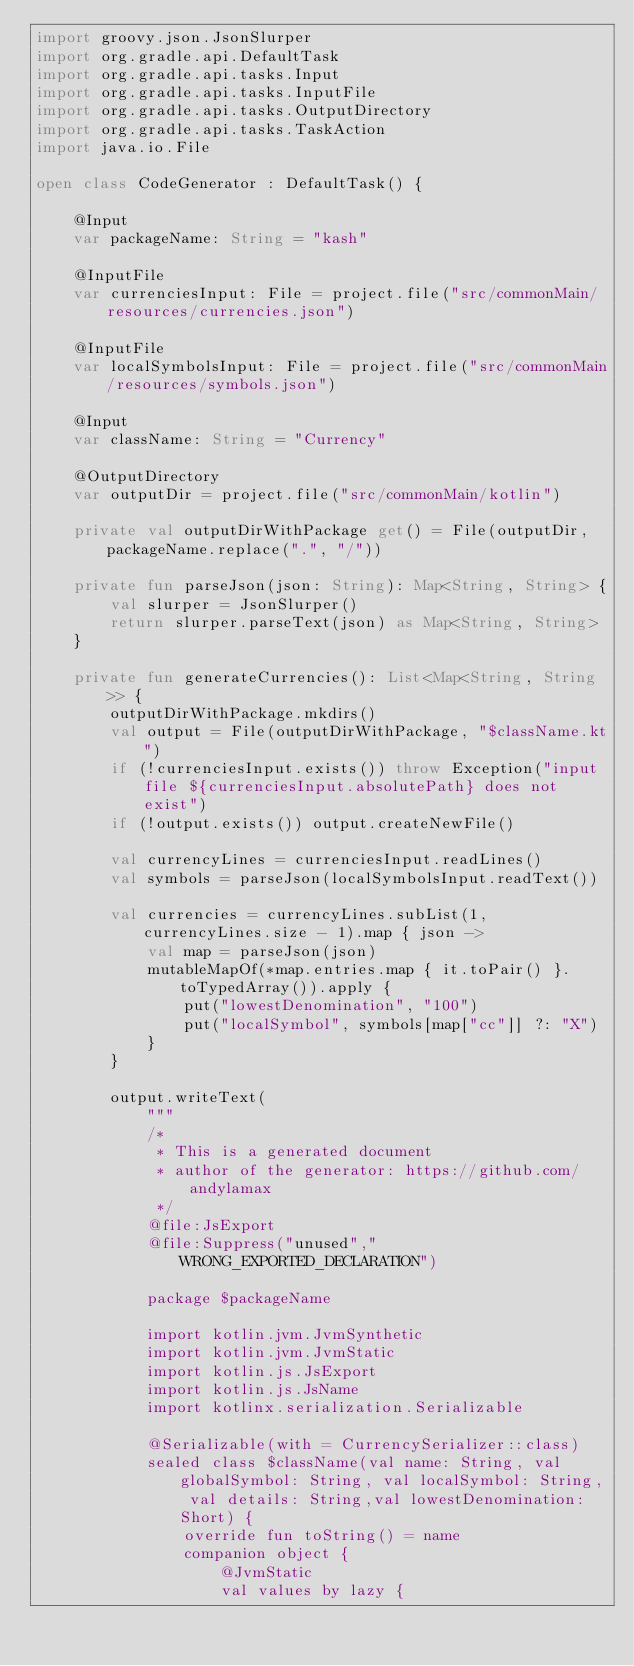Convert code to text. <code><loc_0><loc_0><loc_500><loc_500><_Kotlin_>import groovy.json.JsonSlurper
import org.gradle.api.DefaultTask
import org.gradle.api.tasks.Input
import org.gradle.api.tasks.InputFile
import org.gradle.api.tasks.OutputDirectory
import org.gradle.api.tasks.TaskAction
import java.io.File

open class CodeGenerator : DefaultTask() {

    @Input
    var packageName: String = "kash"

    @InputFile
    var currenciesInput: File = project.file("src/commonMain/resources/currencies.json")

    @InputFile
    var localSymbolsInput: File = project.file("src/commonMain/resources/symbols.json")

    @Input
    var className: String = "Currency"

    @OutputDirectory
    var outputDir = project.file("src/commonMain/kotlin")

    private val outputDirWithPackage get() = File(outputDir, packageName.replace(".", "/"))

    private fun parseJson(json: String): Map<String, String> {
        val slurper = JsonSlurper()
        return slurper.parseText(json) as Map<String, String>
    }

    private fun generateCurrencies(): List<Map<String, String>> {
        outputDirWithPackage.mkdirs()
        val output = File(outputDirWithPackage, "$className.kt")
        if (!currenciesInput.exists()) throw Exception("input file ${currenciesInput.absolutePath} does not exist")
        if (!output.exists()) output.createNewFile()

        val currencyLines = currenciesInput.readLines()
        val symbols = parseJson(localSymbolsInput.readText())

        val currencies = currencyLines.subList(1, currencyLines.size - 1).map { json ->
            val map = parseJson(json)
            mutableMapOf(*map.entries.map { it.toPair() }.toTypedArray()).apply {
                put("lowestDenomination", "100")
                put("localSymbol", symbols[map["cc"]] ?: "X")
            }
        }

        output.writeText(
            """
            /*
             * This is a generated document
             * author of the generator: https://github.com/andylamax
             */
            @file:JsExport
            @file:Suppress("unused","WRONG_EXPORTED_DECLARATION")
            
            package $packageName
            
            import kotlin.jvm.JvmSynthetic
            import kotlin.jvm.JvmStatic
            import kotlin.js.JsExport
            import kotlin.js.JsName
            import kotlinx.serialization.Serializable
            
            @Serializable(with = CurrencySerializer::class)
            sealed class $className(val name: String, val globalSymbol: String, val localSymbol: String, val details: String,val lowestDenomination: Short) {
                override fun toString() = name
                companion object {
                    @JvmStatic
                    val values by lazy { </code> 